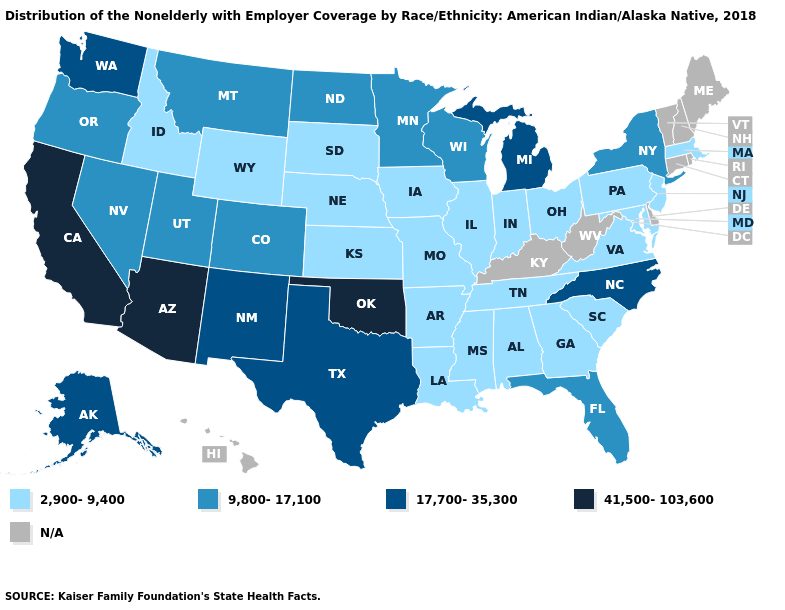Among the states that border Alabama , which have the highest value?
Write a very short answer. Florida. Name the states that have a value in the range N/A?
Be succinct. Connecticut, Delaware, Hawaii, Kentucky, Maine, New Hampshire, Rhode Island, Vermont, West Virginia. Name the states that have a value in the range 2,900-9,400?
Short answer required. Alabama, Arkansas, Georgia, Idaho, Illinois, Indiana, Iowa, Kansas, Louisiana, Maryland, Massachusetts, Mississippi, Missouri, Nebraska, New Jersey, Ohio, Pennsylvania, South Carolina, South Dakota, Tennessee, Virginia, Wyoming. Does the first symbol in the legend represent the smallest category?
Write a very short answer. Yes. Does the map have missing data?
Quick response, please. Yes. What is the lowest value in states that border Wyoming?
Give a very brief answer. 2,900-9,400. What is the value of Iowa?
Concise answer only. 2,900-9,400. What is the lowest value in the West?
Give a very brief answer. 2,900-9,400. Does the map have missing data?
Keep it brief. Yes. Among the states that border Nebraska , which have the lowest value?
Concise answer only. Iowa, Kansas, Missouri, South Dakota, Wyoming. What is the highest value in the USA?
Be succinct. 41,500-103,600. What is the value of Indiana?
Answer briefly. 2,900-9,400. What is the highest value in the Northeast ?
Short answer required. 9,800-17,100. Name the states that have a value in the range 2,900-9,400?
Quick response, please. Alabama, Arkansas, Georgia, Idaho, Illinois, Indiana, Iowa, Kansas, Louisiana, Maryland, Massachusetts, Mississippi, Missouri, Nebraska, New Jersey, Ohio, Pennsylvania, South Carolina, South Dakota, Tennessee, Virginia, Wyoming. 